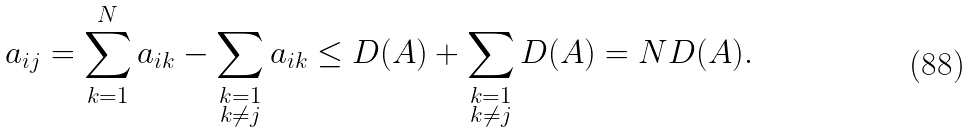Convert formula to latex. <formula><loc_0><loc_0><loc_500><loc_500>a _ { i j } = \sum _ { k = 1 } ^ { N } a _ { i k } - \sum _ { \substack { k = 1 \\ k \ne j \\ } } a _ { i k } \leq D ( A ) + \sum _ { \substack { k = 1 \\ k \ne j \\ } } D ( A ) = N D ( A ) .</formula> 